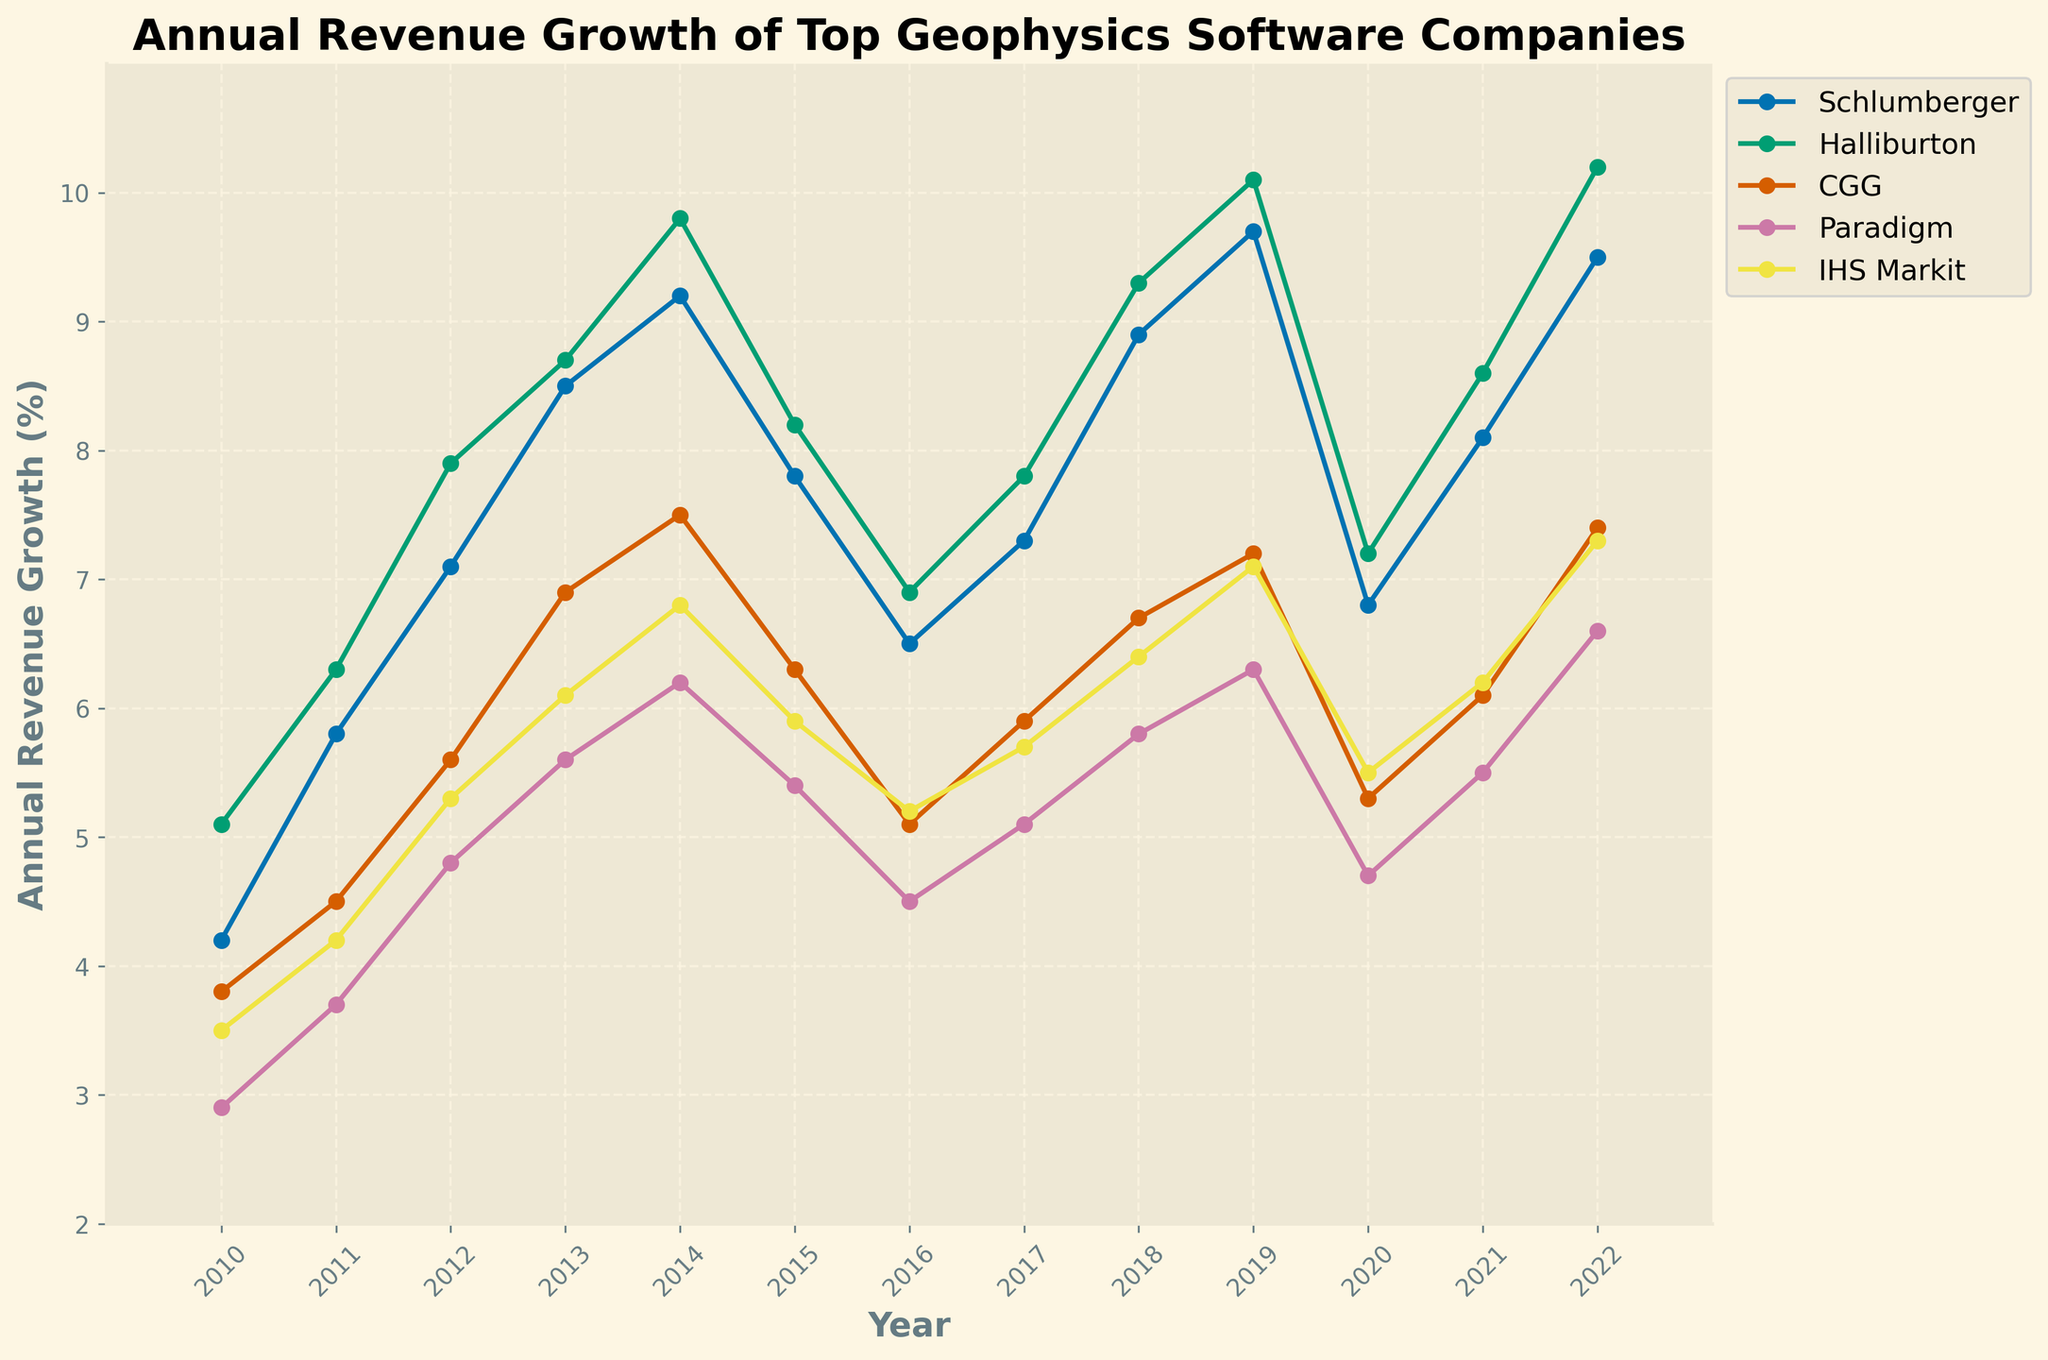Which company had the highest annual revenue growth in 2022? Look at the data points for 2022. Schlumberger had a revenue growth of 9.5, Halliburton had 10.2, CGG had 7.4, Paradigm had 6.6, and IHS Markit had 7.3. Halliburton has the highest value.
Answer: Halliburton Which company showed the most consistent growth from 2010 to 2022? Analyze the trend lines for all companies. Schlumberger's revenue growth generally increases from 2010 to 2022 with some fluctuations, Halliburton shows a similar pattern, while Paradigm, CGG, and IHS Markit are more variable.
Answer: Halliburton In which year did Schlumberger and Halliburton have the closest annual revenue growth? Compare the revenue growth values of Schlumberger and Halliburton for each year. In 2013, Schlumberger had growth of 8.5 and Halliburton had 8.7, making a difference of 0.2, which is the closest.
Answer: 2013 How many years did CGG's annual revenue growth exceed that of Paradigm? Compare the values for CGG and Paradigm for each year from 2010 to 2022. CGG's revenue growth exceeded Paradigm's in 2010, 2011, 2012, 2013, 2014, 2015, 2017, 2018, 2019, 2021, and 2022. That's 11 years in total.
Answer: 11 What was the average annual revenue growth for IHS Markit over the entire period? Sum the annual revenue growth values for IHS Markit from 2010 to 2022 and divide by the number of years (13). The sum is (3.5 + 4.2 + 5.3 + 6.1 + 6.8 + 5.9 + 5.2 + 5.7 + 6.4 + 7.1 + 5.5 + 6.2 + 7.3) = 75.2. The average is 75.2 / 13 = 5.78.
Answer: 5.78 Which company experienced the largest drop in annual revenue growth from one year to the next? Identify the largest decrease between consecutive years for each company. Schlumberger dropped from 9.7 in 2019 to 6.8 in 2020, a drop of 2.9, which is the largest individual drop.
Answer: Schlumberger In which years did all companies experience positive growth? Check all years and verify that no company's growth rate is below zero. From 2010 to 2022, none of the values for any companies are negative. All companies have positive growth in every year.
Answer: 2010-2022 Which company had the highest average growth rate from 2010 to 2014? Calculate the average growth for each company from 2010 to 2014. Sum the values and divide by 5. Schlumberger: (4.2+5.8+7.1+8.5+9.2)/5 = 6.96, Halliburton: (5.1+6.3+7.9+8.7+9.8)/5 = 7.56, CGG: (3.8+4.5+5.6+6.9+7.5)/5 = 5.66, Paradigm: (2.9+3.7+4.8+5.6+6.2)/5 = 4.64, IHS Markit: (3.5+4.2+5.3+6.1+6.8)/5 = 5.18. Halliburton had the highest average.
Answer: Halliburton 